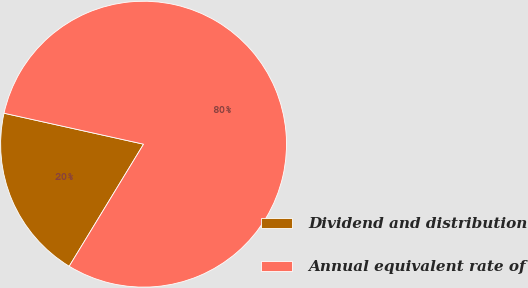Convert chart. <chart><loc_0><loc_0><loc_500><loc_500><pie_chart><fcel>Dividend and distribution<fcel>Annual equivalent rate of<nl><fcel>19.77%<fcel>80.23%<nl></chart> 